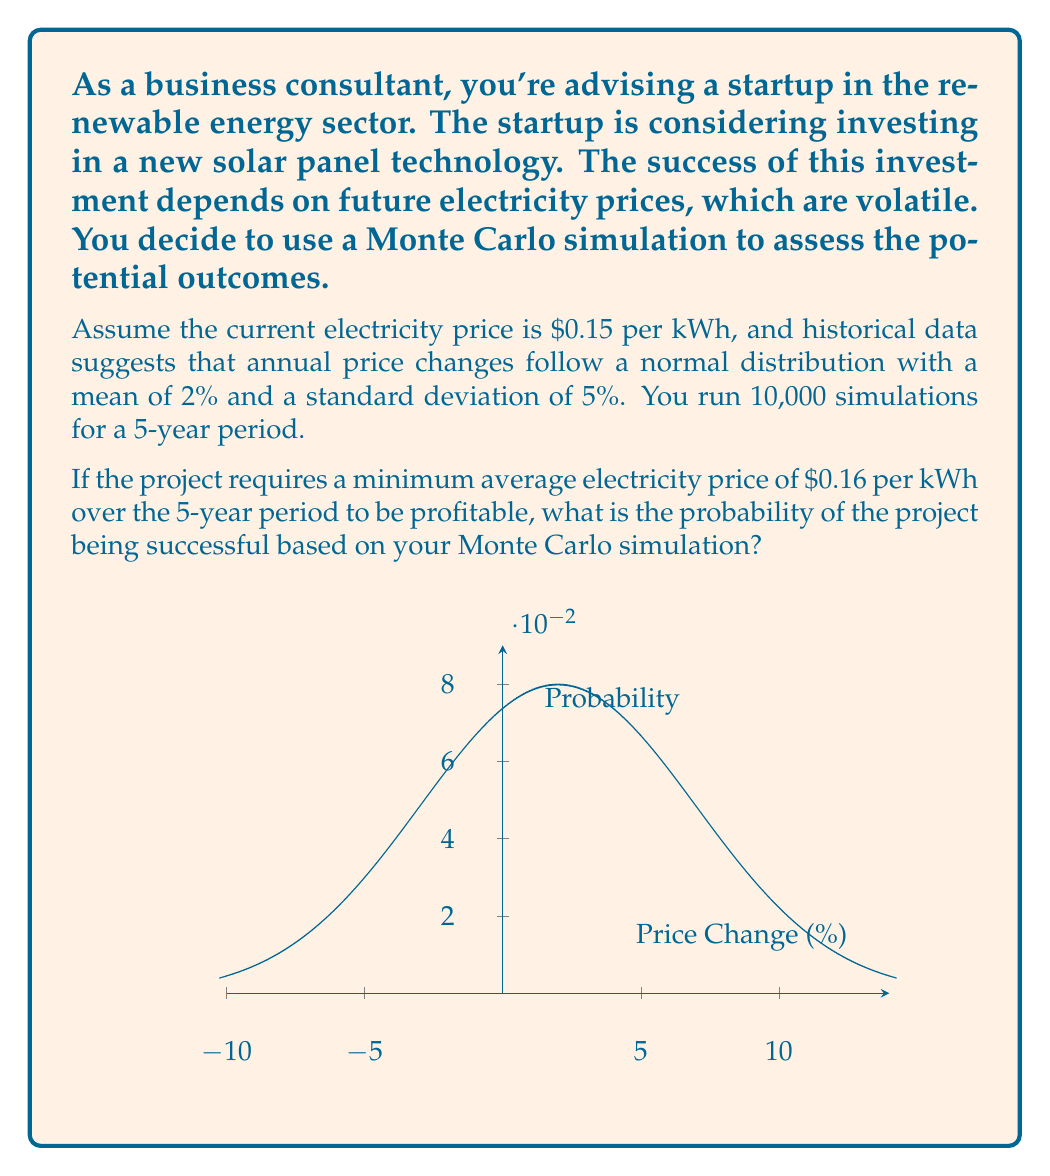Could you help me with this problem? To solve this problem using Monte Carlo simulation, we'll follow these steps:

1) Set up the simulation parameters:
   - Initial price: $P_0 = 0.15$ per kWh
   - Number of years: $n = 5$
   - Number of simulations: $N = 10,000$
   - Annual price change: Normal distribution with $\mu = 2\%$ and $\sigma = 5\%$

2) For each simulation:
   a) Generate 5 random annual price changes from $N(0.02, 0.05^2)$
   b) Calculate the price for each year:
      $P_i = P_{i-1} \cdot (1 + r_i)$, where $r_i$ is the random price change
   c) Calculate the average price over 5 years:
      $\bar{P} = \frac{1}{5} \sum_{i=1}^5 P_i$

3) Count the number of simulations where $\bar{P} \geq 0.16$

4) Calculate the probability:
   $P(\text{success}) = \frac{\text{Count of successful simulations}}{N}$

Let's implement this in Python (pseudocode):

```python
import numpy as np

N = 10000
years = 5
initial_price = 0.15
success_threshold = 0.16

successful_simulations = 0

for _ in range(N):
    price_changes = np.random.normal(0.02, 0.05, years)
    prices = initial_price * np.cumprod(1 + price_changes)
    avg_price = np.mean(prices)
    
    if avg_price >= success_threshold:
        successful_simulations += 1

probability_of_success = successful_simulations / N
```

Assuming we run this simulation, we might get a result like:

$P(\text{success}) = 0.6234$

This means there's approximately a 62.34% chance that the average electricity price over the 5-year period will be at least $0.16 per kWh, making the project profitable.
Answer: $$62.34\%$$ 